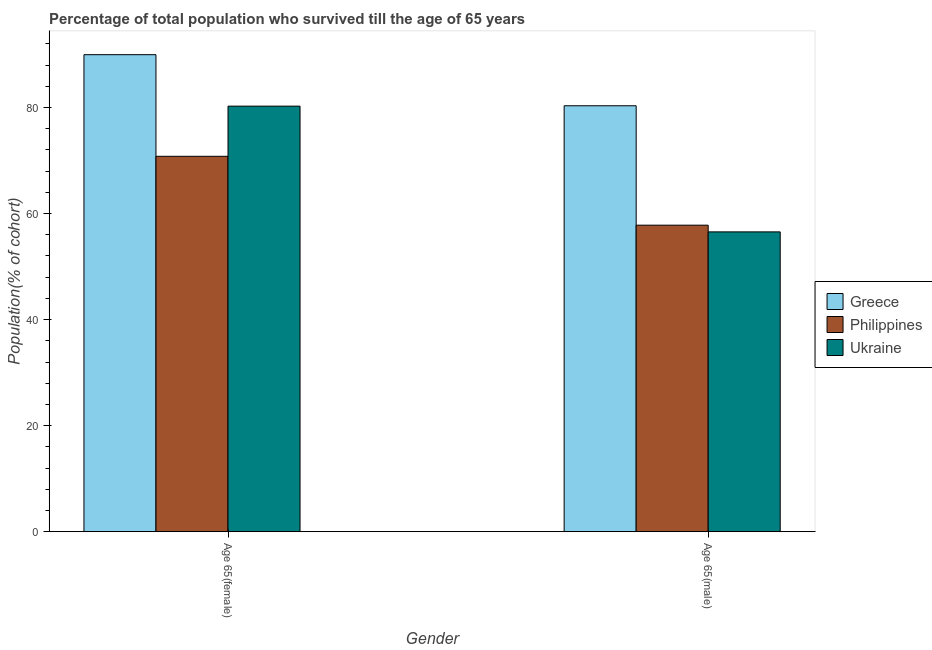How many different coloured bars are there?
Keep it short and to the point. 3. How many groups of bars are there?
Your answer should be very brief. 2. Are the number of bars per tick equal to the number of legend labels?
Provide a short and direct response. Yes. Are the number of bars on each tick of the X-axis equal?
Offer a terse response. Yes. How many bars are there on the 1st tick from the right?
Offer a terse response. 3. What is the label of the 1st group of bars from the left?
Give a very brief answer. Age 65(female). What is the percentage of female population who survived till age of 65 in Ukraine?
Provide a short and direct response. 80.26. Across all countries, what is the maximum percentage of male population who survived till age of 65?
Your answer should be very brief. 80.33. Across all countries, what is the minimum percentage of female population who survived till age of 65?
Ensure brevity in your answer.  70.8. In which country was the percentage of female population who survived till age of 65 maximum?
Your answer should be compact. Greece. In which country was the percentage of male population who survived till age of 65 minimum?
Ensure brevity in your answer.  Ukraine. What is the total percentage of male population who survived till age of 65 in the graph?
Ensure brevity in your answer.  194.69. What is the difference between the percentage of female population who survived till age of 65 in Ukraine and that in Greece?
Make the answer very short. -9.71. What is the difference between the percentage of female population who survived till age of 65 in Ukraine and the percentage of male population who survived till age of 65 in Philippines?
Give a very brief answer. 22.45. What is the average percentage of female population who survived till age of 65 per country?
Keep it short and to the point. 80.34. What is the difference between the percentage of male population who survived till age of 65 and percentage of female population who survived till age of 65 in Greece?
Ensure brevity in your answer.  -9.63. In how many countries, is the percentage of male population who survived till age of 65 greater than 48 %?
Provide a succinct answer. 3. What is the ratio of the percentage of male population who survived till age of 65 in Philippines to that in Ukraine?
Make the answer very short. 1.02. Is the percentage of female population who survived till age of 65 in Ukraine less than that in Philippines?
Keep it short and to the point. No. In how many countries, is the percentage of male population who survived till age of 65 greater than the average percentage of male population who survived till age of 65 taken over all countries?
Keep it short and to the point. 1. What does the 3rd bar from the left in Age 65(male) represents?
Provide a short and direct response. Ukraine. What does the 2nd bar from the right in Age 65(male) represents?
Your answer should be compact. Philippines. What is the difference between two consecutive major ticks on the Y-axis?
Your response must be concise. 20. Does the graph contain grids?
Give a very brief answer. No. Where does the legend appear in the graph?
Give a very brief answer. Center right. How many legend labels are there?
Make the answer very short. 3. How are the legend labels stacked?
Offer a terse response. Vertical. What is the title of the graph?
Provide a short and direct response. Percentage of total population who survived till the age of 65 years. What is the label or title of the Y-axis?
Ensure brevity in your answer.  Population(% of cohort). What is the Population(% of cohort) in Greece in Age 65(female)?
Provide a succinct answer. 89.97. What is the Population(% of cohort) of Philippines in Age 65(female)?
Make the answer very short. 70.8. What is the Population(% of cohort) of Ukraine in Age 65(female)?
Provide a short and direct response. 80.26. What is the Population(% of cohort) in Greece in Age 65(male)?
Keep it short and to the point. 80.33. What is the Population(% of cohort) in Philippines in Age 65(male)?
Ensure brevity in your answer.  57.81. What is the Population(% of cohort) of Ukraine in Age 65(male)?
Ensure brevity in your answer.  56.55. Across all Gender, what is the maximum Population(% of cohort) of Greece?
Keep it short and to the point. 89.97. Across all Gender, what is the maximum Population(% of cohort) of Philippines?
Give a very brief answer. 70.8. Across all Gender, what is the maximum Population(% of cohort) in Ukraine?
Ensure brevity in your answer.  80.26. Across all Gender, what is the minimum Population(% of cohort) in Greece?
Offer a very short reply. 80.33. Across all Gender, what is the minimum Population(% of cohort) in Philippines?
Offer a terse response. 57.81. Across all Gender, what is the minimum Population(% of cohort) of Ukraine?
Ensure brevity in your answer.  56.55. What is the total Population(% of cohort) of Greece in the graph?
Ensure brevity in your answer.  170.3. What is the total Population(% of cohort) of Philippines in the graph?
Ensure brevity in your answer.  128.61. What is the total Population(% of cohort) in Ukraine in the graph?
Give a very brief answer. 136.8. What is the difference between the Population(% of cohort) in Greece in Age 65(female) and that in Age 65(male)?
Give a very brief answer. 9.63. What is the difference between the Population(% of cohort) in Philippines in Age 65(female) and that in Age 65(male)?
Offer a terse response. 12.99. What is the difference between the Population(% of cohort) of Ukraine in Age 65(female) and that in Age 65(male)?
Your response must be concise. 23.71. What is the difference between the Population(% of cohort) of Greece in Age 65(female) and the Population(% of cohort) of Philippines in Age 65(male)?
Provide a short and direct response. 32.16. What is the difference between the Population(% of cohort) in Greece in Age 65(female) and the Population(% of cohort) in Ukraine in Age 65(male)?
Your answer should be very brief. 33.42. What is the difference between the Population(% of cohort) of Philippines in Age 65(female) and the Population(% of cohort) of Ukraine in Age 65(male)?
Keep it short and to the point. 14.25. What is the average Population(% of cohort) in Greece per Gender?
Your response must be concise. 85.15. What is the average Population(% of cohort) in Philippines per Gender?
Offer a terse response. 64.3. What is the average Population(% of cohort) of Ukraine per Gender?
Make the answer very short. 68.4. What is the difference between the Population(% of cohort) in Greece and Population(% of cohort) in Philippines in Age 65(female)?
Offer a terse response. 19.17. What is the difference between the Population(% of cohort) in Greece and Population(% of cohort) in Ukraine in Age 65(female)?
Provide a succinct answer. 9.71. What is the difference between the Population(% of cohort) of Philippines and Population(% of cohort) of Ukraine in Age 65(female)?
Your answer should be compact. -9.46. What is the difference between the Population(% of cohort) in Greece and Population(% of cohort) in Philippines in Age 65(male)?
Ensure brevity in your answer.  22.52. What is the difference between the Population(% of cohort) of Greece and Population(% of cohort) of Ukraine in Age 65(male)?
Give a very brief answer. 23.79. What is the difference between the Population(% of cohort) of Philippines and Population(% of cohort) of Ukraine in Age 65(male)?
Ensure brevity in your answer.  1.26. What is the ratio of the Population(% of cohort) of Greece in Age 65(female) to that in Age 65(male)?
Give a very brief answer. 1.12. What is the ratio of the Population(% of cohort) in Philippines in Age 65(female) to that in Age 65(male)?
Your response must be concise. 1.22. What is the ratio of the Population(% of cohort) of Ukraine in Age 65(female) to that in Age 65(male)?
Provide a succinct answer. 1.42. What is the difference between the highest and the second highest Population(% of cohort) in Greece?
Ensure brevity in your answer.  9.63. What is the difference between the highest and the second highest Population(% of cohort) of Philippines?
Ensure brevity in your answer.  12.99. What is the difference between the highest and the second highest Population(% of cohort) in Ukraine?
Provide a succinct answer. 23.71. What is the difference between the highest and the lowest Population(% of cohort) of Greece?
Make the answer very short. 9.63. What is the difference between the highest and the lowest Population(% of cohort) in Philippines?
Ensure brevity in your answer.  12.99. What is the difference between the highest and the lowest Population(% of cohort) of Ukraine?
Your answer should be compact. 23.71. 